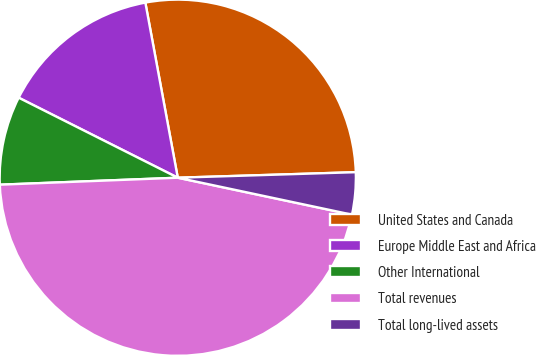Convert chart. <chart><loc_0><loc_0><loc_500><loc_500><pie_chart><fcel>United States and Canada<fcel>Europe Middle East and Africa<fcel>Other International<fcel>Total revenues<fcel>Total long-lived assets<nl><fcel>27.42%<fcel>14.67%<fcel>8.04%<fcel>46.05%<fcel>3.82%<nl></chart> 